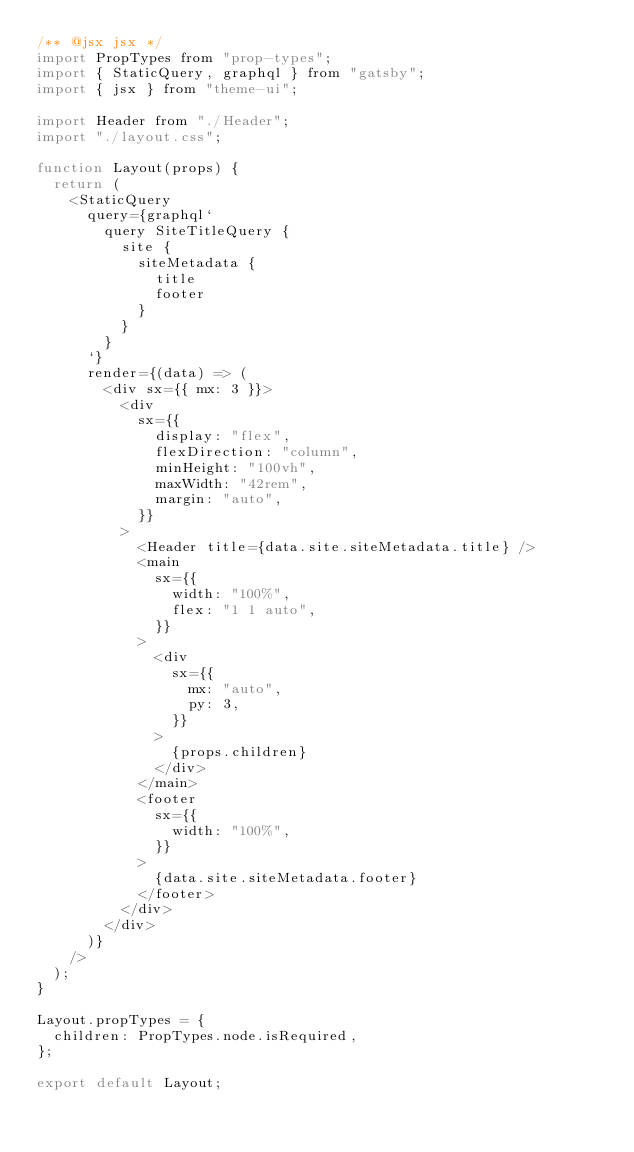Convert code to text. <code><loc_0><loc_0><loc_500><loc_500><_JavaScript_>/** @jsx jsx */
import PropTypes from "prop-types";
import { StaticQuery, graphql } from "gatsby";
import { jsx } from "theme-ui";

import Header from "./Header";
import "./layout.css";

function Layout(props) {
  return (
    <StaticQuery
      query={graphql`
        query SiteTitleQuery {
          site {
            siteMetadata {
              title
              footer
            }
          }
        }
      `}
      render={(data) => (
        <div sx={{ mx: 3 }}>
          <div
            sx={{
              display: "flex",
              flexDirection: "column",
              minHeight: "100vh",
              maxWidth: "42rem",
              margin: "auto",
            }}
          >
            <Header title={data.site.siteMetadata.title} />
            <main
              sx={{
                width: "100%",
                flex: "1 1 auto",
              }}
            >
              <div
                sx={{
                  mx: "auto",
                  py: 3,
                }}
              >
                {props.children}
              </div>
            </main>
            <footer
              sx={{
                width: "100%",
              }}
            >
              {data.site.siteMetadata.footer}
            </footer>
          </div>
        </div>
      )}
    />
  );
}

Layout.propTypes = {
  children: PropTypes.node.isRequired,
};

export default Layout;
</code> 